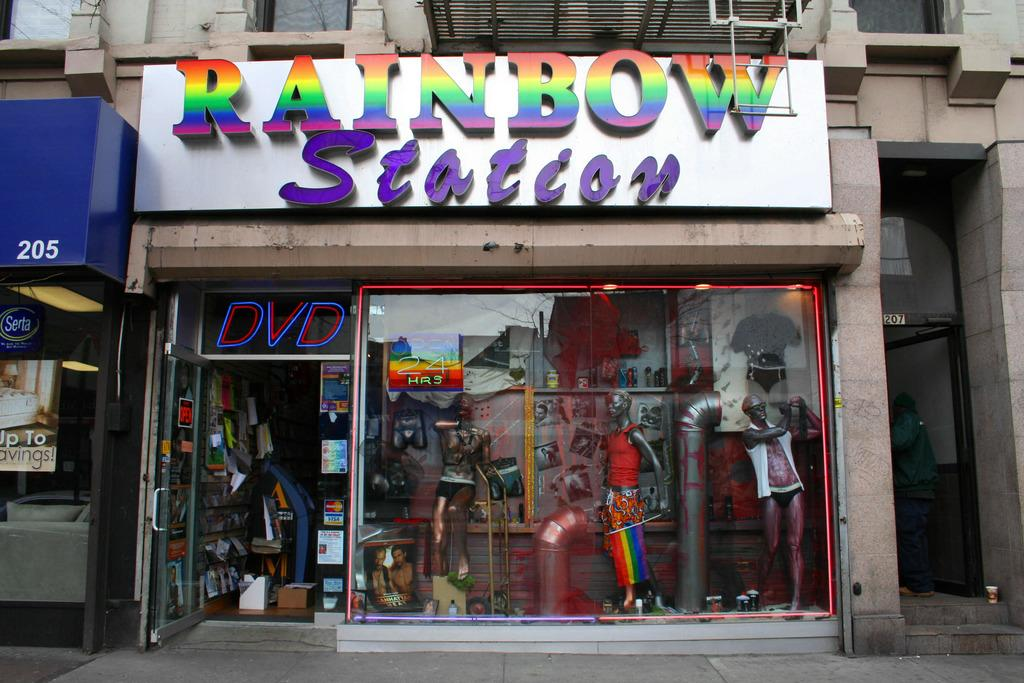<image>
Describe the image concisely. a Rainbow store with rainbow colors on it 